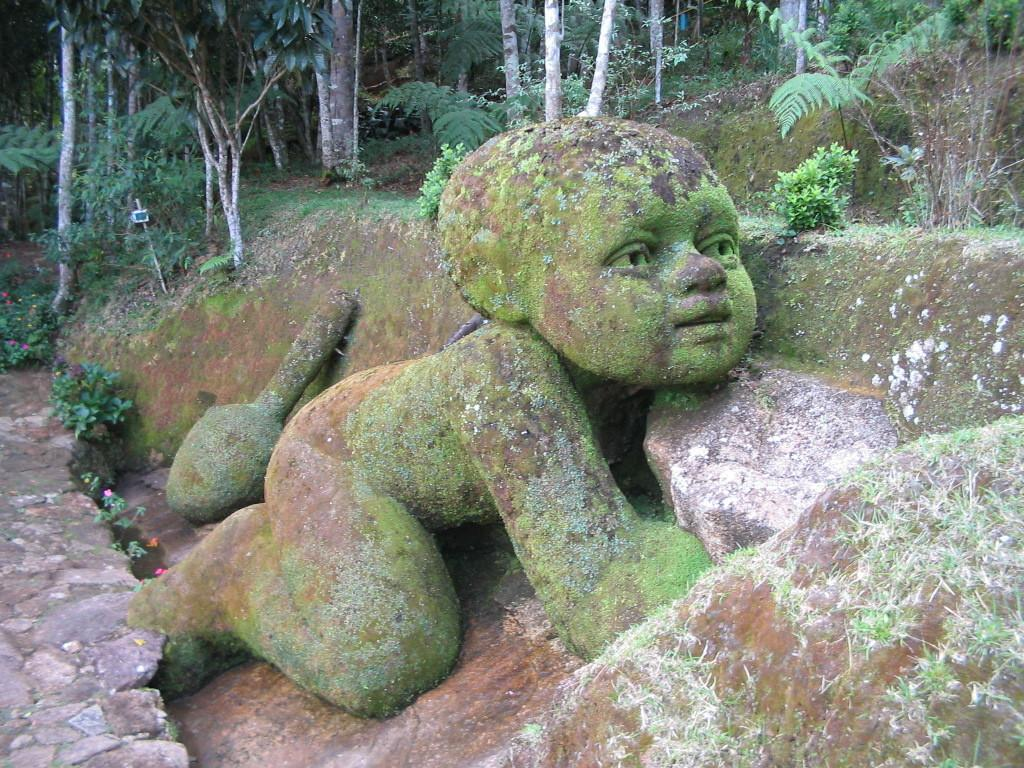What is the main subject of the image? There is a sculpture in the image. What type of natural environment is depicted in the image? There is grass, plants with flowers, and a group of trees in the image. Are there any man-made structures or objects in the image? Yes, there is a pole in the image. What type of toy can be seen in the image? There is no toy present in the image. Can you describe the nose of the person in the image? There is no person depicted in the image, only a sculpture. 